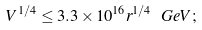<formula> <loc_0><loc_0><loc_500><loc_500>V ^ { 1 / 4 } \leq 3 . 3 \times 1 0 ^ { 1 6 } r ^ { 1 / 4 } \ G e V ;</formula> 